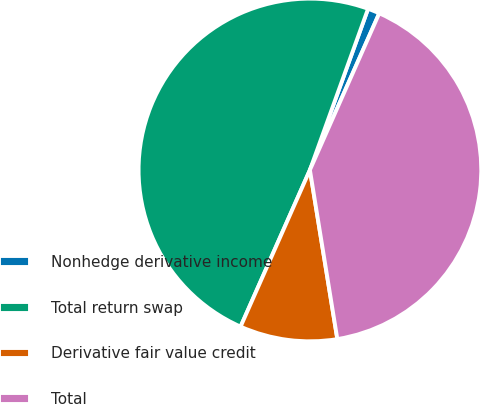Convert chart to OTSL. <chart><loc_0><loc_0><loc_500><loc_500><pie_chart><fcel>Nonhedge derivative income<fcel>Total return swap<fcel>Derivative fair value credit<fcel>Total<nl><fcel>1.12%<fcel>48.88%<fcel>9.19%<fcel>40.81%<nl></chart> 